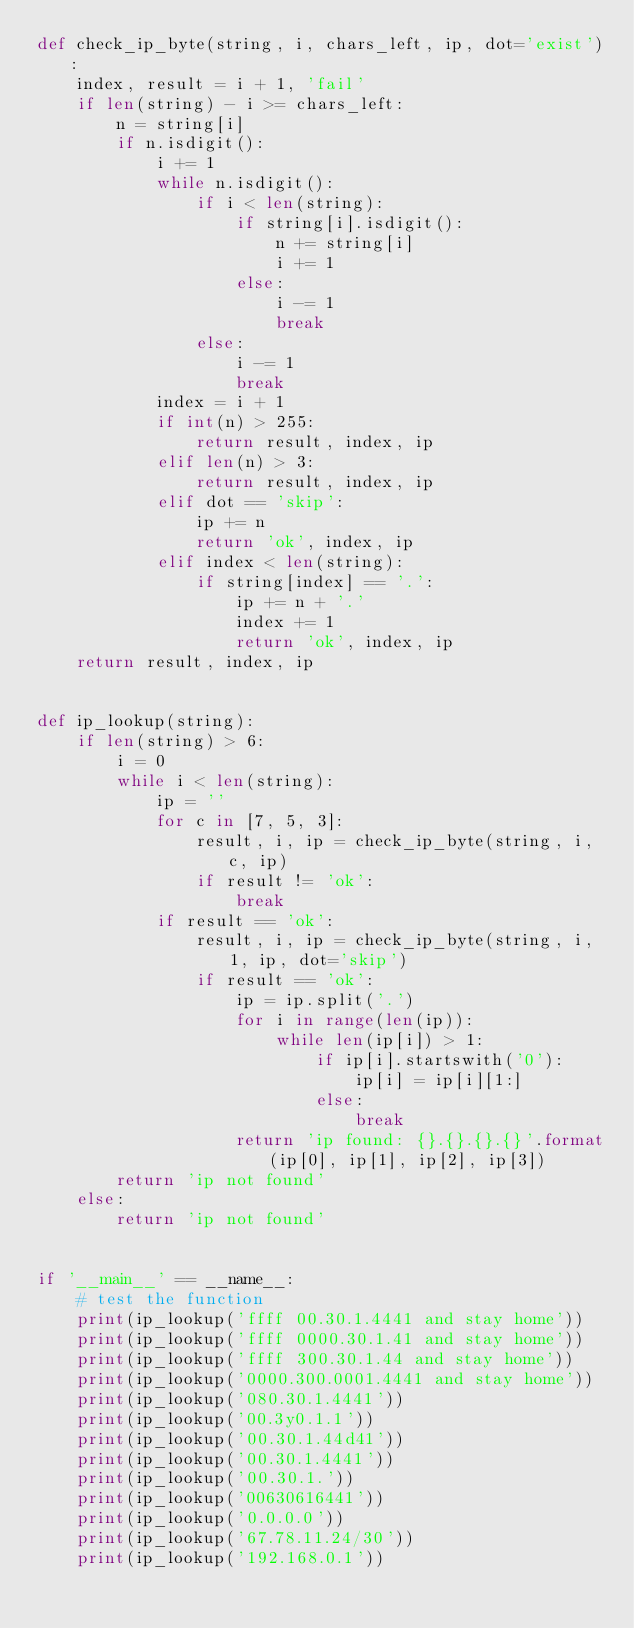Convert code to text. <code><loc_0><loc_0><loc_500><loc_500><_Python_>def check_ip_byte(string, i, chars_left, ip, dot='exist'):
    index, result = i + 1, 'fail'
    if len(string) - i >= chars_left:
        n = string[i]
        if n.isdigit():
            i += 1
            while n.isdigit():
                if i < len(string):
                    if string[i].isdigit():
                        n += string[i]
                        i += 1
                    else:
                        i -= 1
                        break
                else:
                    i -= 1
                    break
            index = i + 1
            if int(n) > 255:
                return result, index, ip
            elif len(n) > 3:
                return result, index, ip
            elif dot == 'skip':
                ip += n
                return 'ok', index, ip
            elif index < len(string):
                if string[index] == '.':
                    ip += n + '.'
                    index += 1
                    return 'ok', index, ip
    return result, index, ip


def ip_lookup(string):
    if len(string) > 6:
        i = 0
        while i < len(string):
            ip = ''
            for c in [7, 5, 3]:
                result, i, ip = check_ip_byte(string, i, c, ip)
                if result != 'ok':
                    break
            if result == 'ok':
                result, i, ip = check_ip_byte(string, i, 1, ip, dot='skip')
                if result == 'ok':
                    ip = ip.split('.')
                    for i in range(len(ip)):
                        while len(ip[i]) > 1:
                            if ip[i].startswith('0'):
                                ip[i] = ip[i][1:]
                            else:
                                break
                    return 'ip found: {}.{}.{}.{}'.format(ip[0], ip[1], ip[2], ip[3])
        return 'ip not found'
    else:
        return 'ip not found'


if '__main__' == __name__:
    # test the function
    print(ip_lookup('ffff 00.30.1.4441 and stay home'))
    print(ip_lookup('ffff 0000.30.1.41 and stay home'))
    print(ip_lookup('ffff 300.30.1.44 and stay home'))
    print(ip_lookup('0000.300.0001.4441 and stay home'))
    print(ip_lookup('080.30.1.4441'))
    print(ip_lookup('00.3y0.1.1'))
    print(ip_lookup('00.30.1.44d41'))
    print(ip_lookup('00.30.1.4441'))
    print(ip_lookup('00.30.1.'))
    print(ip_lookup('00630616441'))
    print(ip_lookup('0.0.0.0'))
    print(ip_lookup('67.78.11.24/30'))
    print(ip_lookup('192.168.0.1'))</code> 